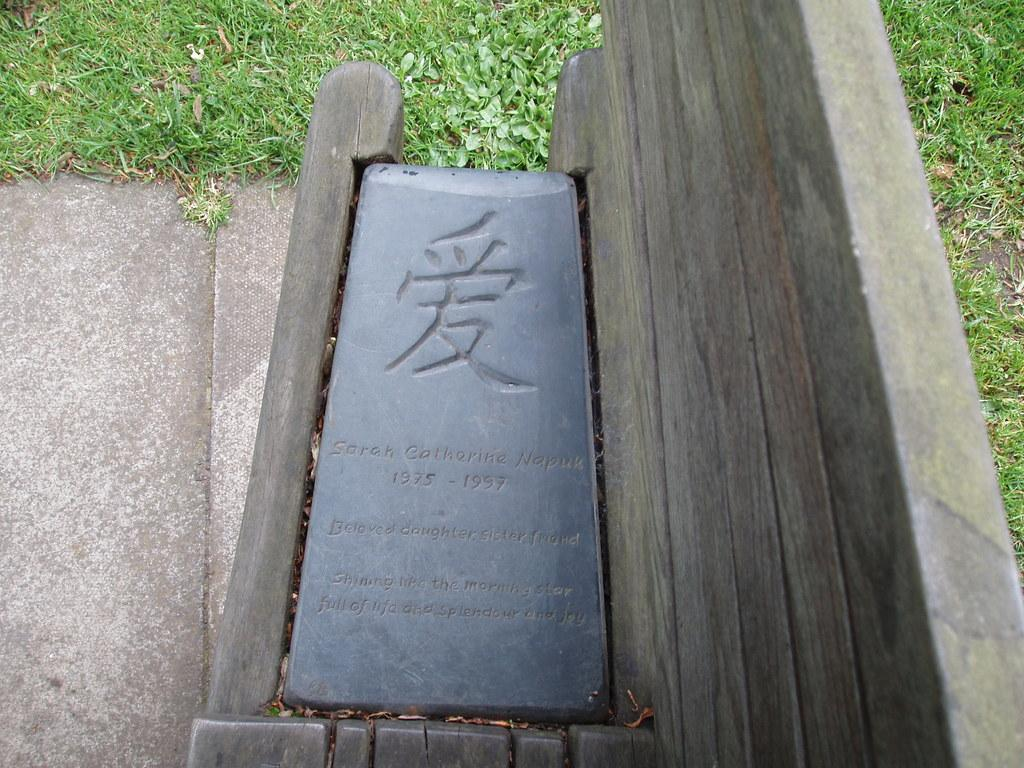What is the main object in the image? There is a stone board in the image. Where is the stone board located? The stone board is on a wooden bench. What is the wooden bench resting on? The wooden bench is on the ground. What can be seen in the background of the image? There is grass visible in the background of the image. How many nails can be seen holding the stone board to the wooden bench in the image? There are no nails visible in the image; the stone board is simply placed on the wooden bench. 